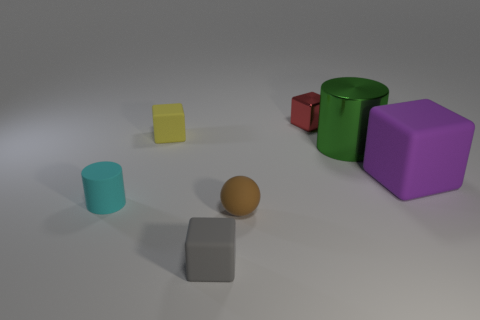Subtract 1 blocks. How many blocks are left? 3 Add 1 purple things. How many objects exist? 8 Subtract all blocks. How many objects are left? 3 Add 6 brown rubber objects. How many brown rubber objects exist? 7 Subtract 0 red cylinders. How many objects are left? 7 Subtract all purple rubber objects. Subtract all purple metal spheres. How many objects are left? 6 Add 1 blocks. How many blocks are left? 5 